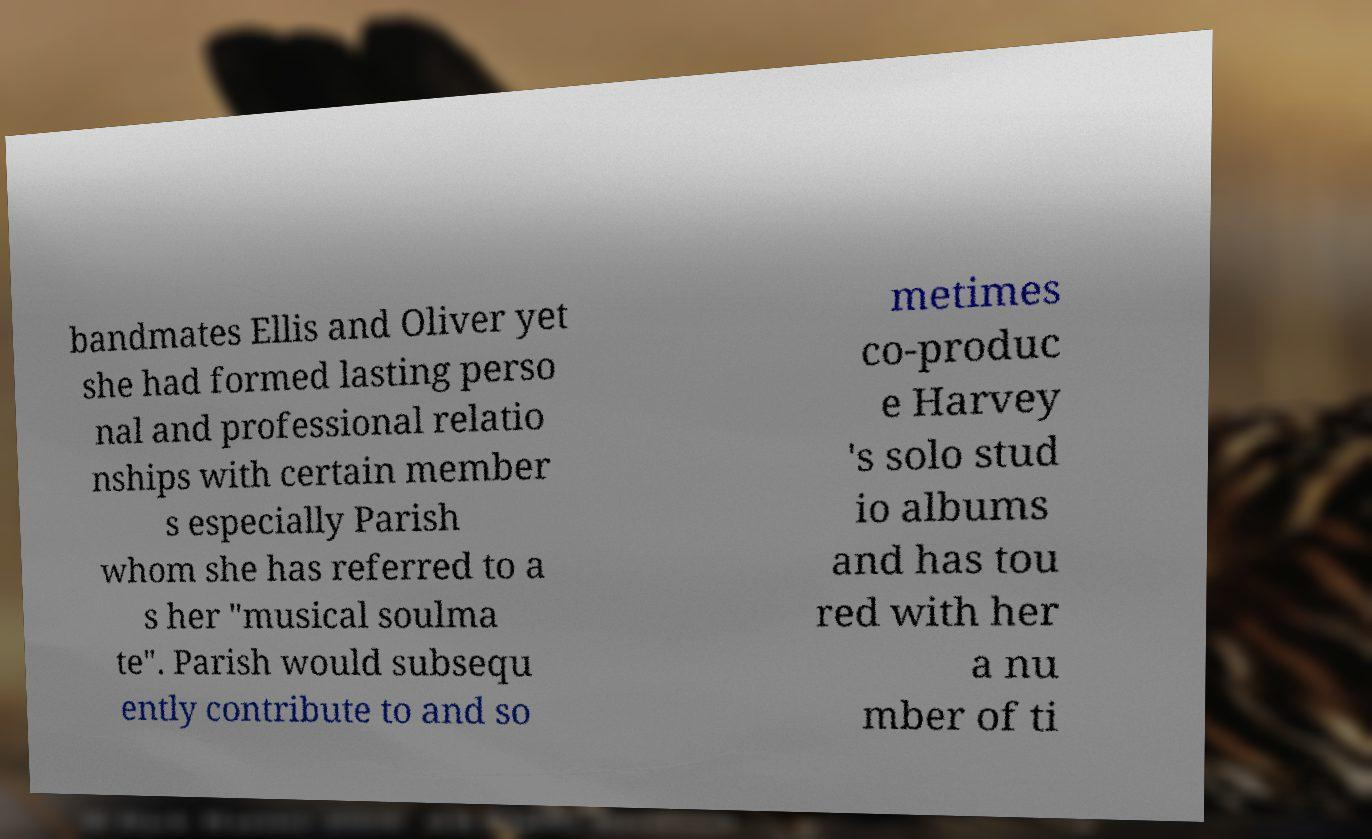There's text embedded in this image that I need extracted. Can you transcribe it verbatim? bandmates Ellis and Oliver yet she had formed lasting perso nal and professional relatio nships with certain member s especially Parish whom she has referred to a s her "musical soulma te". Parish would subsequ ently contribute to and so metimes co-produc e Harvey 's solo stud io albums and has tou red with her a nu mber of ti 